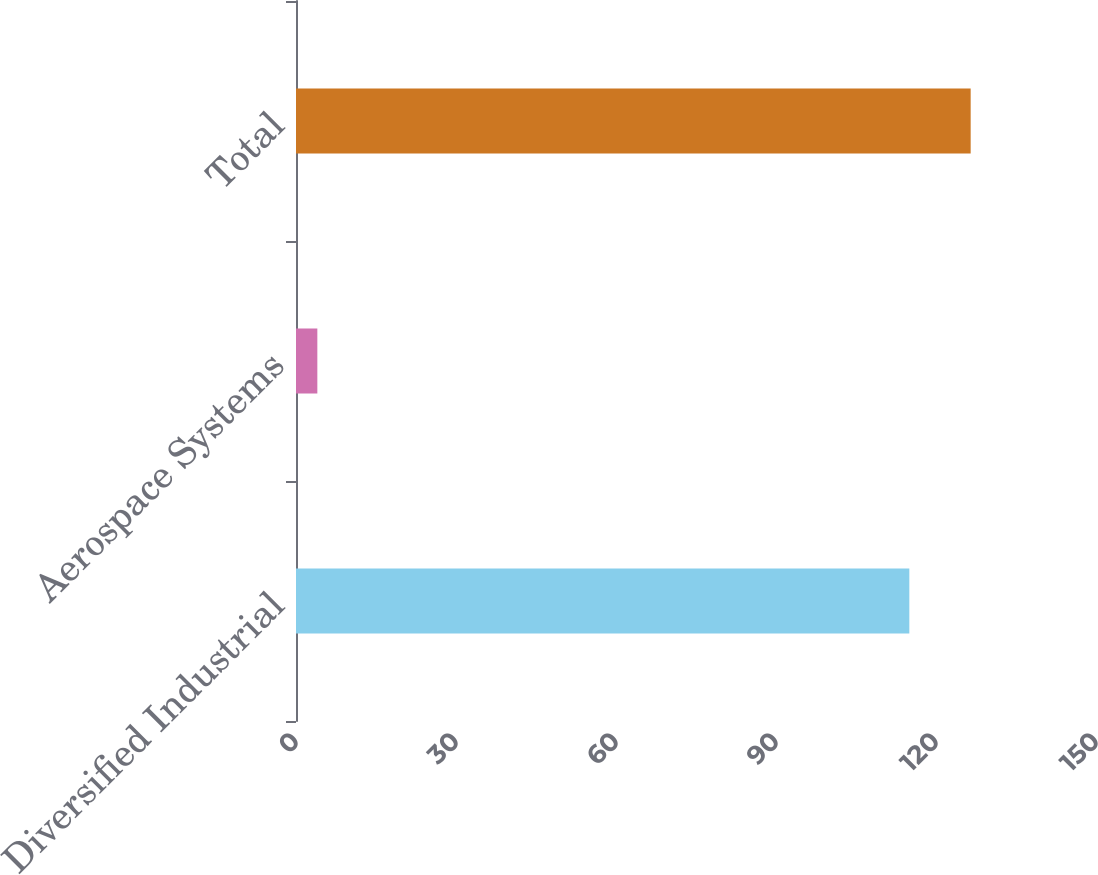Convert chart to OTSL. <chart><loc_0><loc_0><loc_500><loc_500><bar_chart><fcel>Diversified Industrial<fcel>Aerospace Systems<fcel>Total<nl><fcel>115<fcel>4<fcel>126.5<nl></chart> 